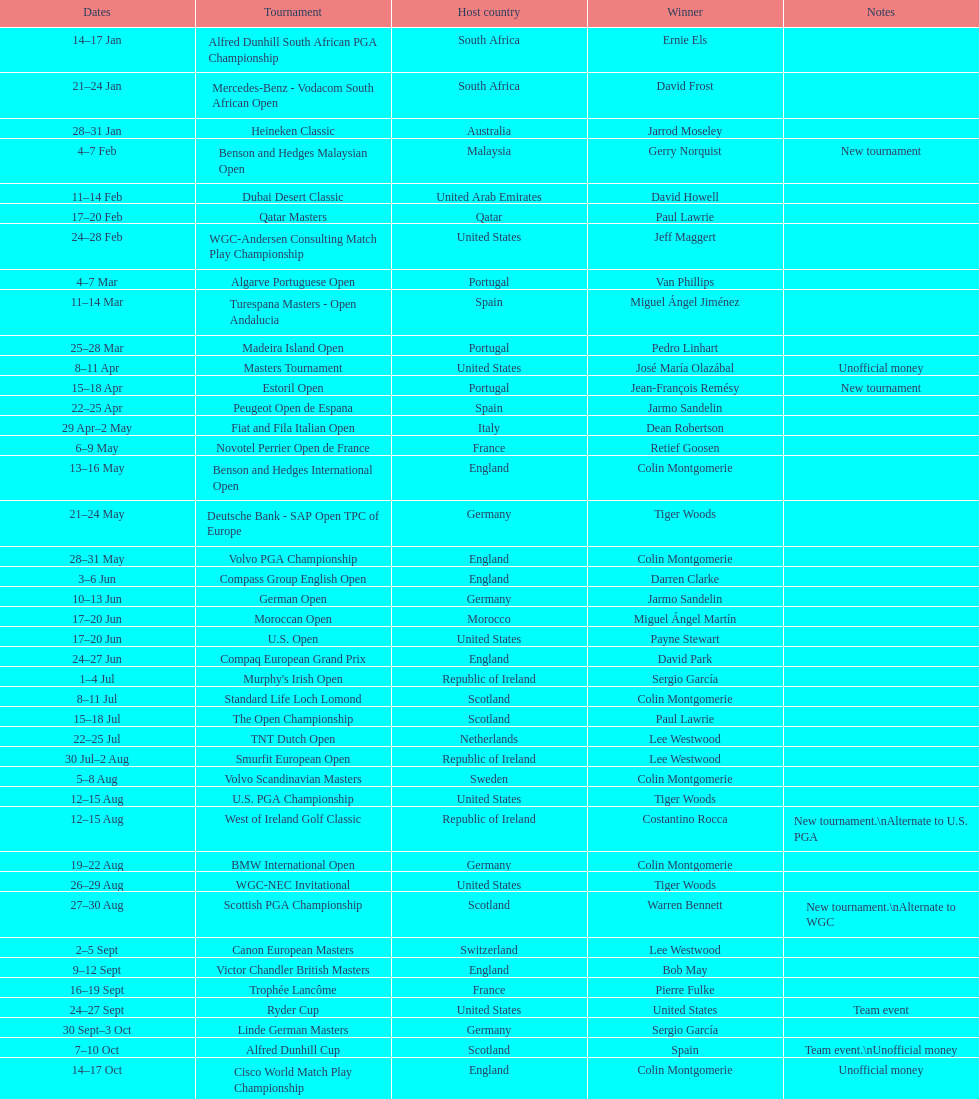Could you parse the entire table as a dict? {'header': ['Dates', 'Tournament', 'Host country', 'Winner', 'Notes'], 'rows': [['14–17\xa0Jan', 'Alfred Dunhill South African PGA Championship', 'South Africa', 'Ernie Els', ''], ['21–24\xa0Jan', 'Mercedes-Benz - Vodacom South African Open', 'South Africa', 'David Frost', ''], ['28–31\xa0Jan', 'Heineken Classic', 'Australia', 'Jarrod Moseley', ''], ['4–7\xa0Feb', 'Benson and Hedges Malaysian Open', 'Malaysia', 'Gerry Norquist', 'New tournament'], ['11–14\xa0Feb', 'Dubai Desert Classic', 'United Arab Emirates', 'David Howell', ''], ['17–20\xa0Feb', 'Qatar Masters', 'Qatar', 'Paul Lawrie', ''], ['24–28\xa0Feb', 'WGC-Andersen Consulting Match Play Championship', 'United States', 'Jeff Maggert', ''], ['4–7\xa0Mar', 'Algarve Portuguese Open', 'Portugal', 'Van Phillips', ''], ['11–14\xa0Mar', 'Turespana Masters - Open Andalucia', 'Spain', 'Miguel Ángel Jiménez', ''], ['25–28\xa0Mar', 'Madeira Island Open', 'Portugal', 'Pedro Linhart', ''], ['8–11\xa0Apr', 'Masters Tournament', 'United States', 'José María Olazábal', 'Unofficial money'], ['15–18\xa0Apr', 'Estoril Open', 'Portugal', 'Jean-François Remésy', 'New tournament'], ['22–25\xa0Apr', 'Peugeot Open de Espana', 'Spain', 'Jarmo Sandelin', ''], ['29\xa0Apr–2\xa0May', 'Fiat and Fila Italian Open', 'Italy', 'Dean Robertson', ''], ['6–9\xa0May', 'Novotel Perrier Open de France', 'France', 'Retief Goosen', ''], ['13–16\xa0May', 'Benson and Hedges International Open', 'England', 'Colin Montgomerie', ''], ['21–24\xa0May', 'Deutsche Bank - SAP Open TPC of Europe', 'Germany', 'Tiger Woods', ''], ['28–31\xa0May', 'Volvo PGA Championship', 'England', 'Colin Montgomerie', ''], ['3–6\xa0Jun', 'Compass Group English Open', 'England', 'Darren Clarke', ''], ['10–13\xa0Jun', 'German Open', 'Germany', 'Jarmo Sandelin', ''], ['17–20\xa0Jun', 'Moroccan Open', 'Morocco', 'Miguel Ángel Martín', ''], ['17–20\xa0Jun', 'U.S. Open', 'United States', 'Payne Stewart', ''], ['24–27\xa0Jun', 'Compaq European Grand Prix', 'England', 'David Park', ''], ['1–4\xa0Jul', "Murphy's Irish Open", 'Republic of Ireland', 'Sergio García', ''], ['8–11\xa0Jul', 'Standard Life Loch Lomond', 'Scotland', 'Colin Montgomerie', ''], ['15–18\xa0Jul', 'The Open Championship', 'Scotland', 'Paul Lawrie', ''], ['22–25\xa0Jul', 'TNT Dutch Open', 'Netherlands', 'Lee Westwood', ''], ['30\xa0Jul–2\xa0Aug', 'Smurfit European Open', 'Republic of Ireland', 'Lee Westwood', ''], ['5–8\xa0Aug', 'Volvo Scandinavian Masters', 'Sweden', 'Colin Montgomerie', ''], ['12–15\xa0Aug', 'U.S. PGA Championship', 'United States', 'Tiger Woods', ''], ['12–15\xa0Aug', 'West of Ireland Golf Classic', 'Republic of Ireland', 'Costantino Rocca', 'New tournament.\\nAlternate to U.S. PGA'], ['19–22\xa0Aug', 'BMW International Open', 'Germany', 'Colin Montgomerie', ''], ['26–29\xa0Aug', 'WGC-NEC Invitational', 'United States', 'Tiger Woods', ''], ['27–30\xa0Aug', 'Scottish PGA Championship', 'Scotland', 'Warren Bennett', 'New tournament.\\nAlternate to WGC'], ['2–5\xa0Sept', 'Canon European Masters', 'Switzerland', 'Lee Westwood', ''], ['9–12\xa0Sept', 'Victor Chandler British Masters', 'England', 'Bob May', ''], ['16–19\xa0Sept', 'Trophée Lancôme', 'France', 'Pierre Fulke', ''], ['24–27\xa0Sept', 'Ryder Cup', 'United States', 'United States', 'Team event'], ['30\xa0Sept–3\xa0Oct', 'Linde German Masters', 'Germany', 'Sergio García', ''], ['7–10\xa0Oct', 'Alfred Dunhill Cup', 'Scotland', 'Spain', 'Team event.\\nUnofficial money'], ['14–17\xa0Oct', 'Cisco World Match Play Championship', 'England', 'Colin Montgomerie', 'Unofficial money'], ['14–17\xa0Oct', 'Sarazen World Open', 'Spain', 'Thomas Bjørn', 'New tournament'], ['21–24\xa0Oct', 'Belgacom Open', 'Belgium', 'Robert Karlsson', ''], ['28–31\xa0Oct', 'Volvo Masters', 'Spain', 'Miguel Ángel Jiménez', ''], ['4–7\xa0Nov', 'WGC-American Express Championship', 'Spain', 'Tiger Woods', ''], ['18–21\xa0Nov', 'World Cup of Golf', 'Malaysia', 'United States', 'Team event.\\nUnofficial money']]} How lengthy was the estoril open? 3 days. 